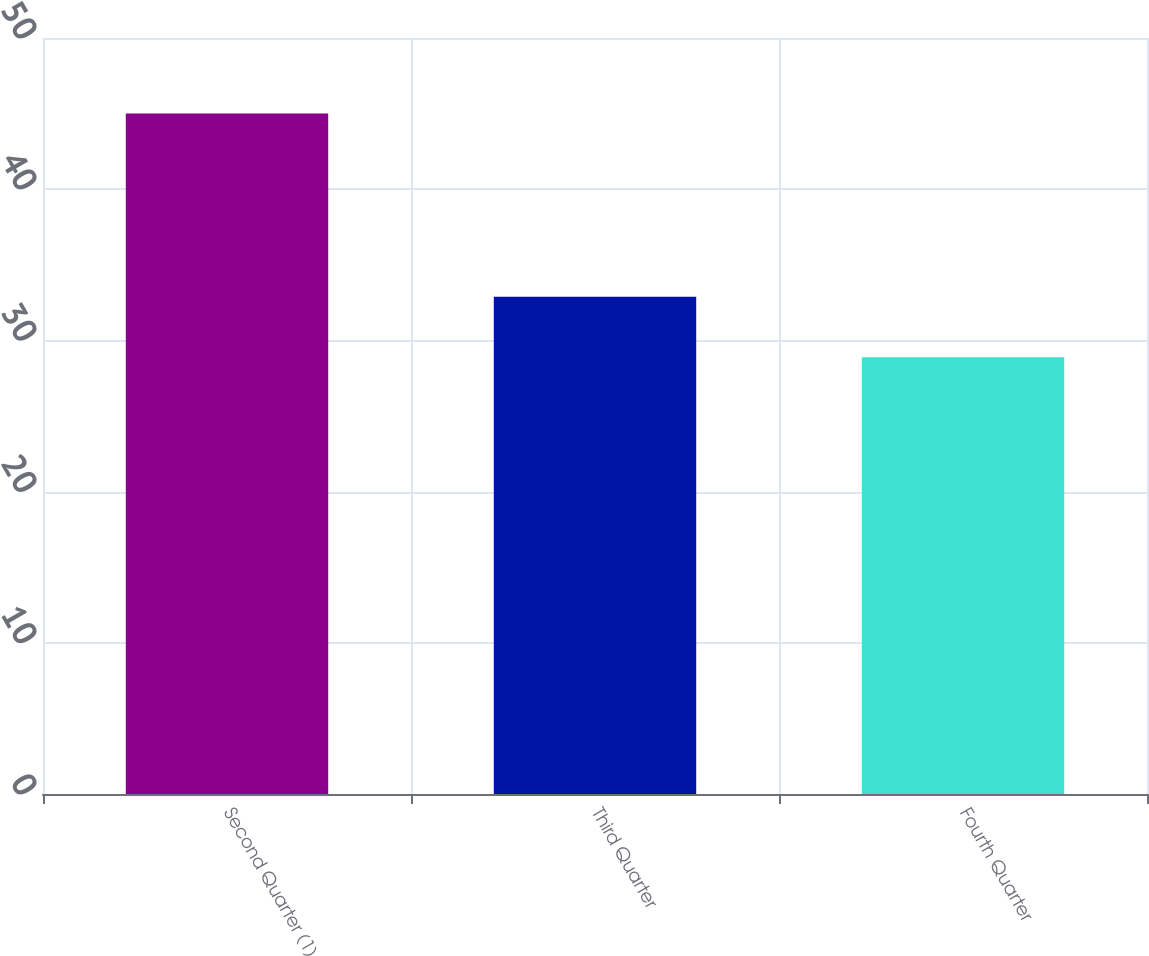<chart> <loc_0><loc_0><loc_500><loc_500><bar_chart><fcel>Second Quarter (1)<fcel>Third Quarter<fcel>Fourth Quarter<nl><fcel>45<fcel>32.88<fcel>28.88<nl></chart> 